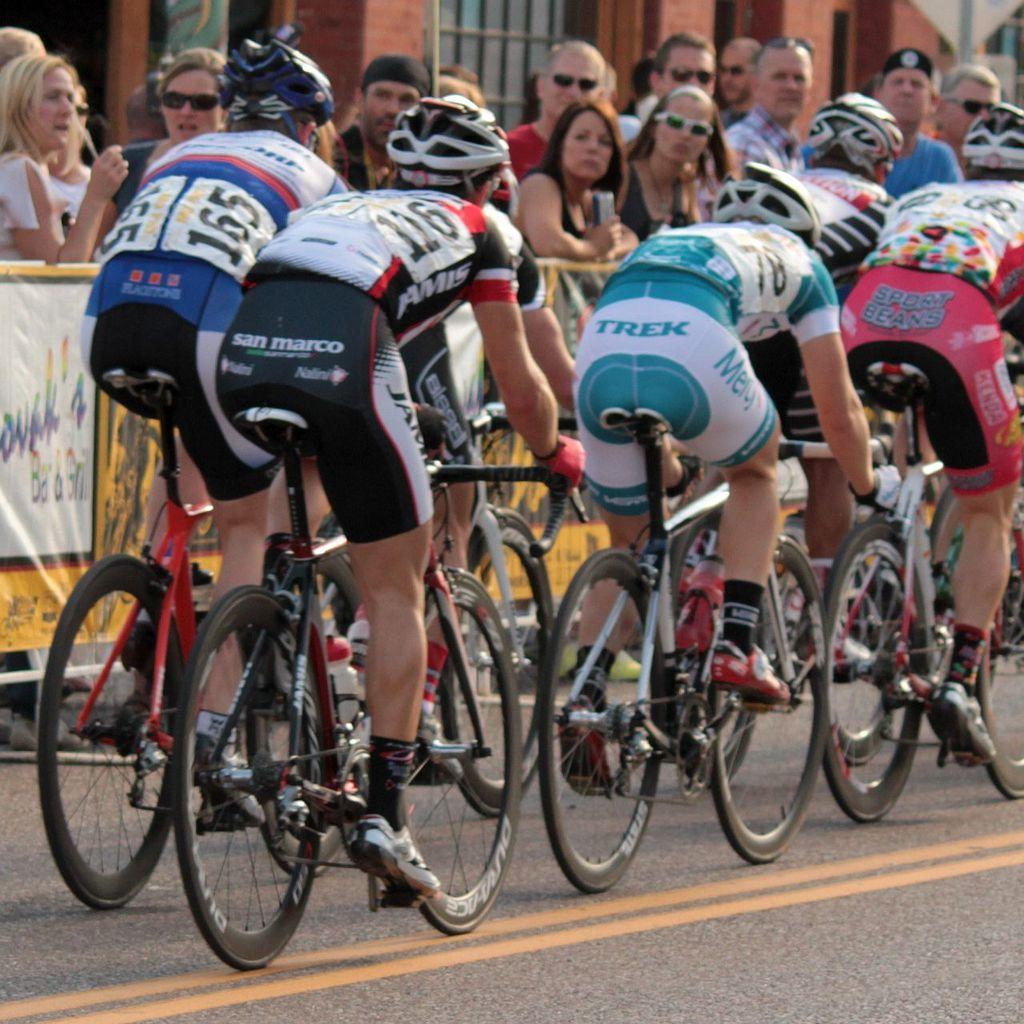In one or two sentences, can you explain what this image depicts? There are group of people wearing helmets, sitting on bicycles and cycling on the road. In the background, other people are watching them, building, window made up with glass, and a sign board. 